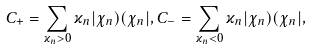<formula> <loc_0><loc_0><loc_500><loc_500>C _ { + } = \sum _ { \varkappa _ { n } > 0 } \varkappa _ { n } | \chi _ { n } ) ( \chi _ { n } | , C _ { - } = \sum _ { \varkappa _ { n } < 0 } \varkappa _ { n } | \chi _ { n } ) ( \chi _ { n } | ,</formula> 